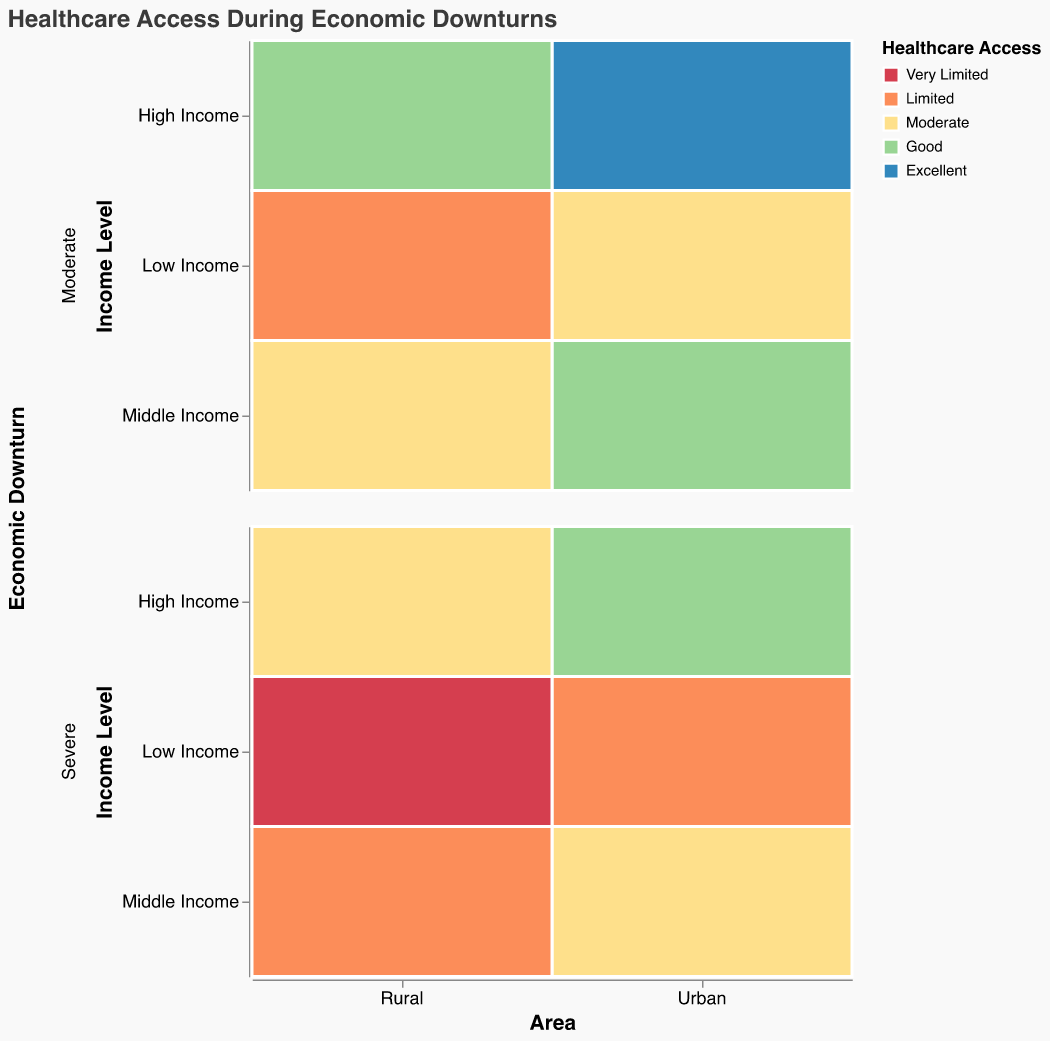What is the title of the plot? The title of the plot is located at the top and provides a summary of the plot's content. This helps the viewer understand the context of the data being presented.
Answer: Healthcare Access During Economic Downturns Which area has the worst healthcare access for low-income populations during severe economic downturns? To identify the worst healthcare access for low-income populations, look at the "Low Income" and "Severe" rows for both Urban and Rural areas. "Very Limited" healthcare access is worse than "Limited".
Answer: Rural In urban areas, how does healthcare access for middle-income populations compare between moderate and severe economic downturns? Compare the rows for "Urban" and "Middle Income" across both "Moderate" and "Severe" downturns to see which has better access (e.g., "Good" vs. "Moderate").
Answer: During moderate downturns, healthcare access is "Good", while in severe downturns it is "Moderate" How does healthcare access for high-income populations differ between urban and rural areas during severe economic downturns? Check the rows for "High Income" in both Urban and Rural columns during severe downturns and compare the healthcare access values.
Answer: Healthcare access is "Good" in Urban areas and "Moderate" in Rural areas What is the general trend of healthcare access for low-income populations between urban and rural areas? Look at the healthcare access values for "Low Income" populations in both Urban and Rural areas and note the differences. Rural areas have "Very Limited" and "Limited" compared to Urban areas which have "Limited" and "Moderate".
Answer: Rural areas generally have worse healthcare access than urban areas Which group has the best healthcare access during moderate economic downturns? Identify which combination of area and income level has the most favorable healthcare access label ("Excellent", "Good", etc.) during moderate economic downturns.
Answer: Urban high-income populations How does the healthcare access for middle-income populations in rural areas change from moderate to severe economic downturns? Examine the healthcare access for "Rural" and "Middle Income" in both "Moderate" and "Severe" downturn rows.
Answer: It changes from "Moderate" during moderate downturns to "Limited" during severe downturns Is there a higher variety of healthcare access levels in urban or rural areas? Assess the different labels used under 'Healthcare Access' for both Urban and Rural areas to determine which has more variety.
Answer: Urban During severe economic downturns, what is the healthcare access level for high-income urban populations? Look at the healthcare access for "Urban" and "High Income" during "Severe" economic downturns.
Answer: Good Are rural high-income populations affected more or less by economic downturns compared to urban high-income populations? Compare the differences in healthcare access levels during moderate and severe downturns for high-income groups in both Urban and Rural areas.
Answer: Rural high-income populations have worse healthcare access than urban high-income populations during severe downturns 